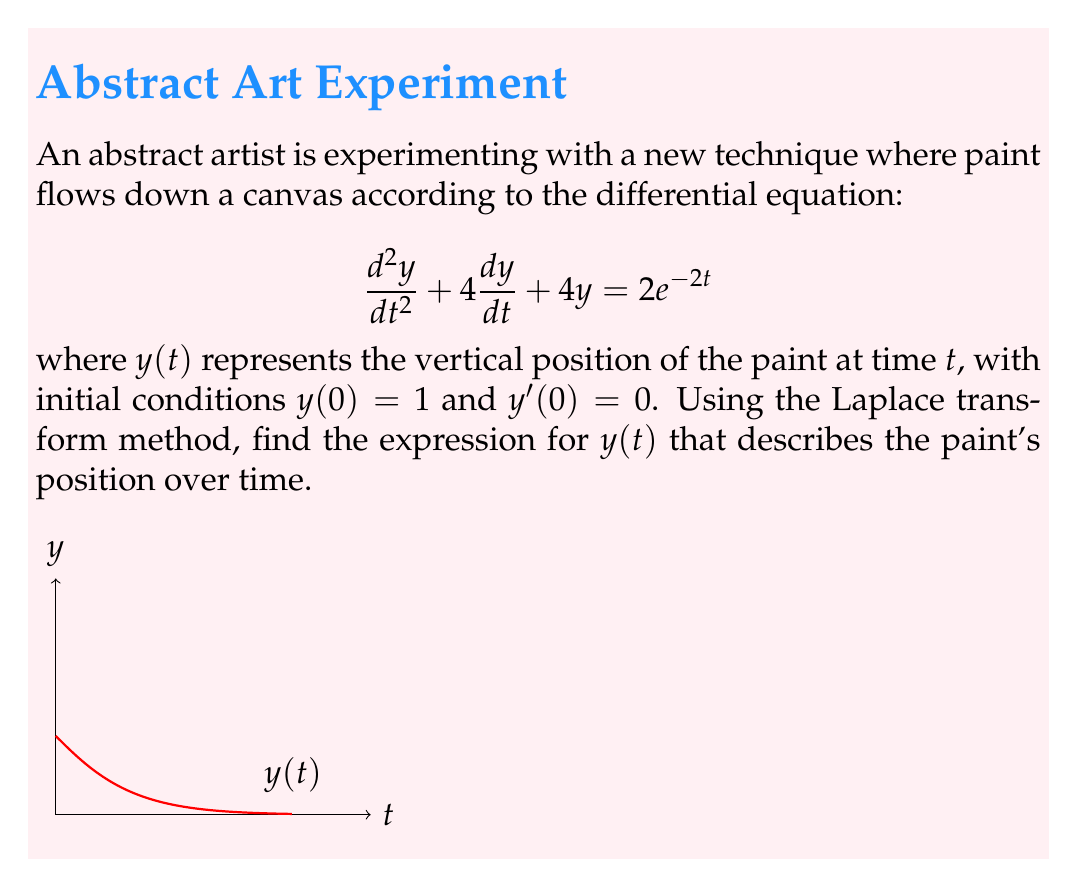Teach me how to tackle this problem. Let's solve this step-by-step using the Laplace transform:

1) Take the Laplace transform of both sides of the equation:
   $$\mathcal{L}\{y''\} + 4\mathcal{L}\{y'\} + 4\mathcal{L}\{y\} = \mathcal{L}\{2e^{-2t}\}$$

2) Use Laplace transform properties:
   $$s^2Y(s) - sy(0) - y'(0) + 4[sY(s) - y(0)] + 4Y(s) = \frac{2}{s+2}$$

3) Substitute initial conditions $y(0) = 1$ and $y'(0) = 0$:
   $$s^2Y(s) - s + 4sY(s) - 4 + 4Y(s) = \frac{2}{s+2}$$

4) Simplify:
   $$(s^2 + 4s + 4)Y(s) = \frac{2}{s+2} + s + 4$$

5) Factor the left side:
   $$(s + 2)^2Y(s) = \frac{2}{s+2} + s + 4$$

6) Solve for Y(s):
   $$Y(s) = \frac{2}{(s+2)^3} + \frac{s+4}{(s+2)^2}$$

7) Decompose into partial fractions:
   $$Y(s) = \frac{2}{(s+2)^3} + \frac{1}{s+2} + \frac{1}{(s+2)^2}$$

8) Take the inverse Laplace transform:
   $$y(t) = \mathcal{L}^{-1}\{\frac{2}{(s+2)^3}\} + \mathcal{L}^{-1}\{\frac{1}{s+2}\} + \mathcal{L}^{-1}\{\frac{1}{(s+2)^2}\}$$

9) Use inverse Laplace transform properties:
   $$y(t) = t^2e^{-2t} + e^{-2t} + te^{-2t}$$

10) Simplify:
    $$y(t) = (1 + t + t^2)e^{-2t}$$
Answer: $y(t) = (1 + t + t^2)e^{-2t}$ 